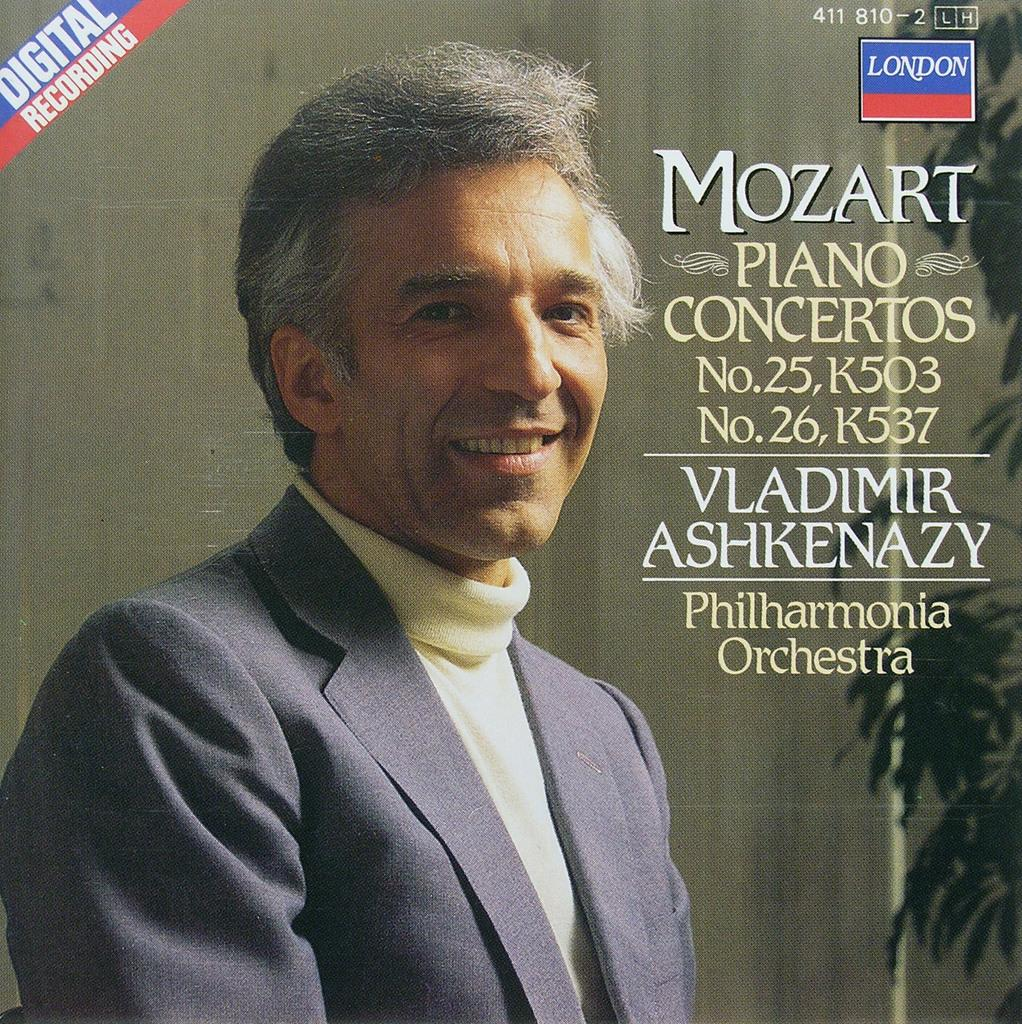Provide a one-sentence caption for the provided image. a photo of a man on for a music album that says Digital Recording on it. 